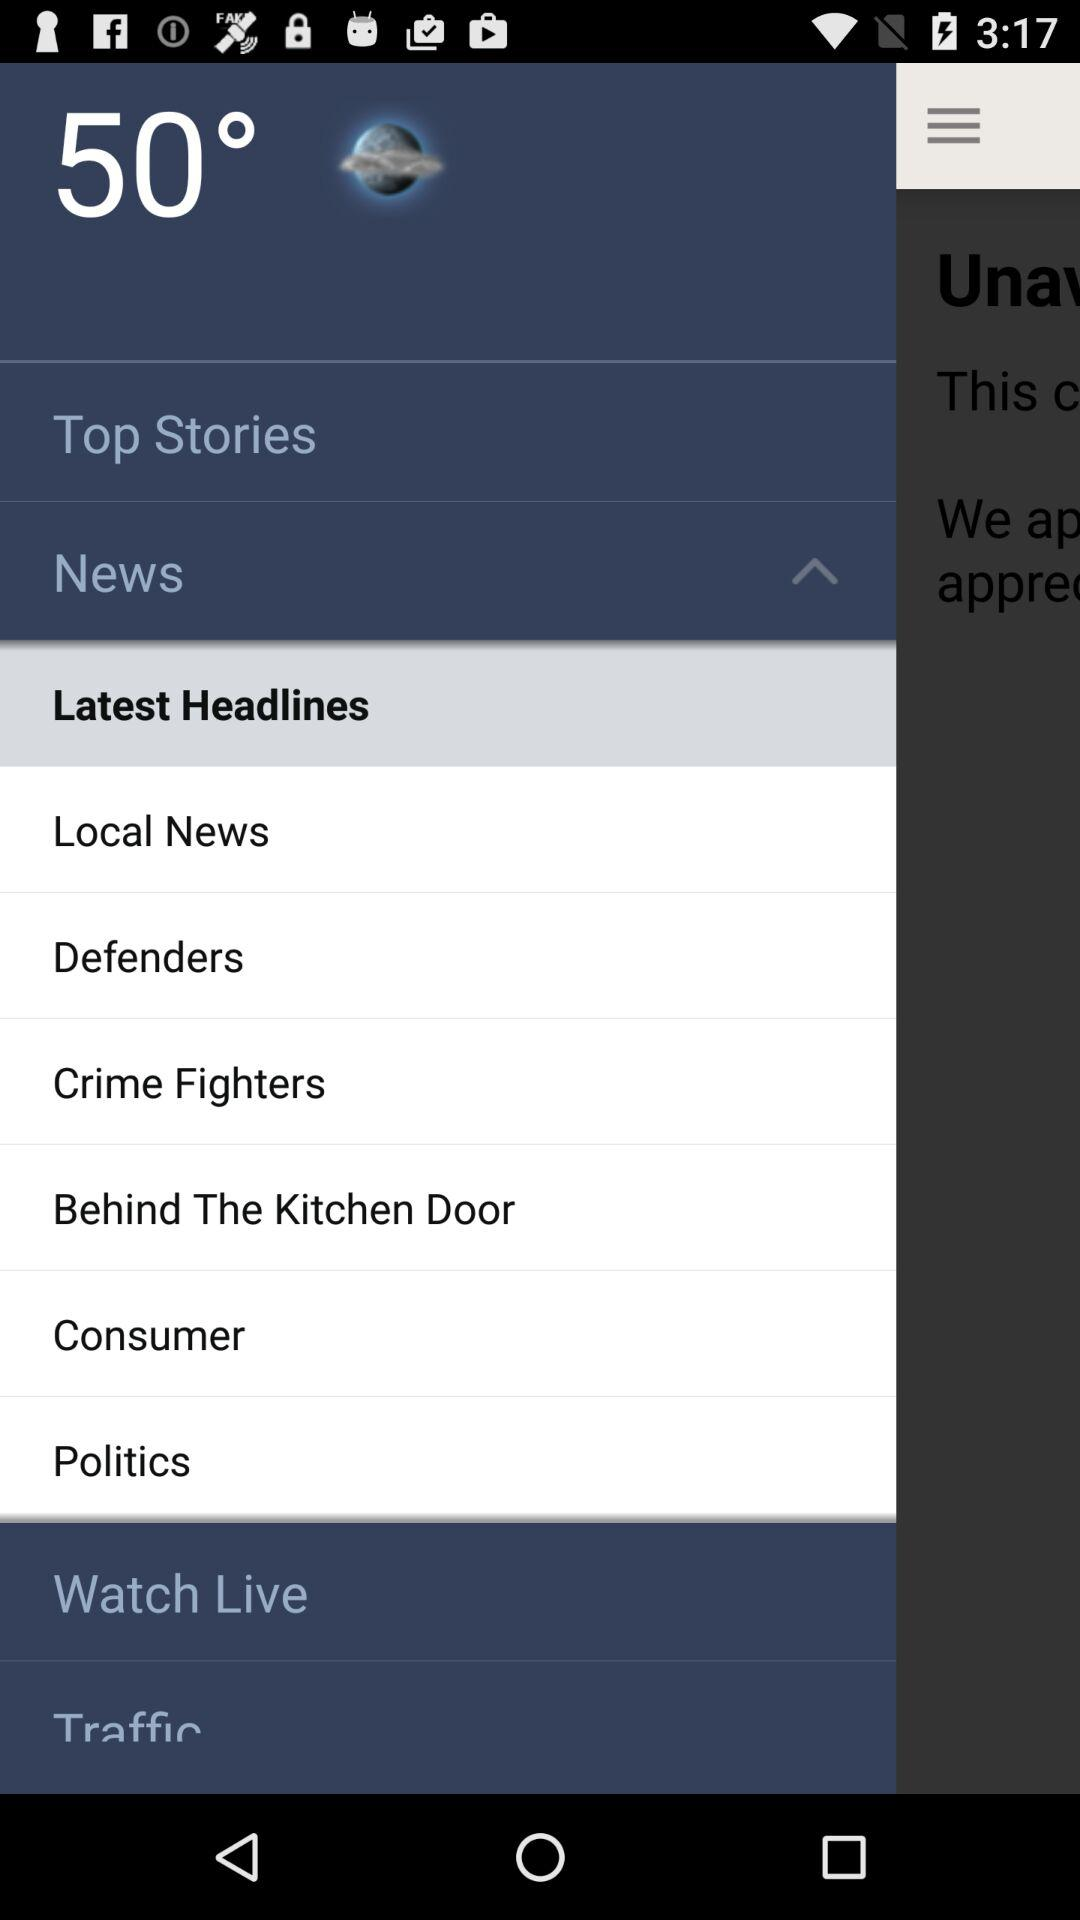What is the temperature? The temperature is 50 degrees. 